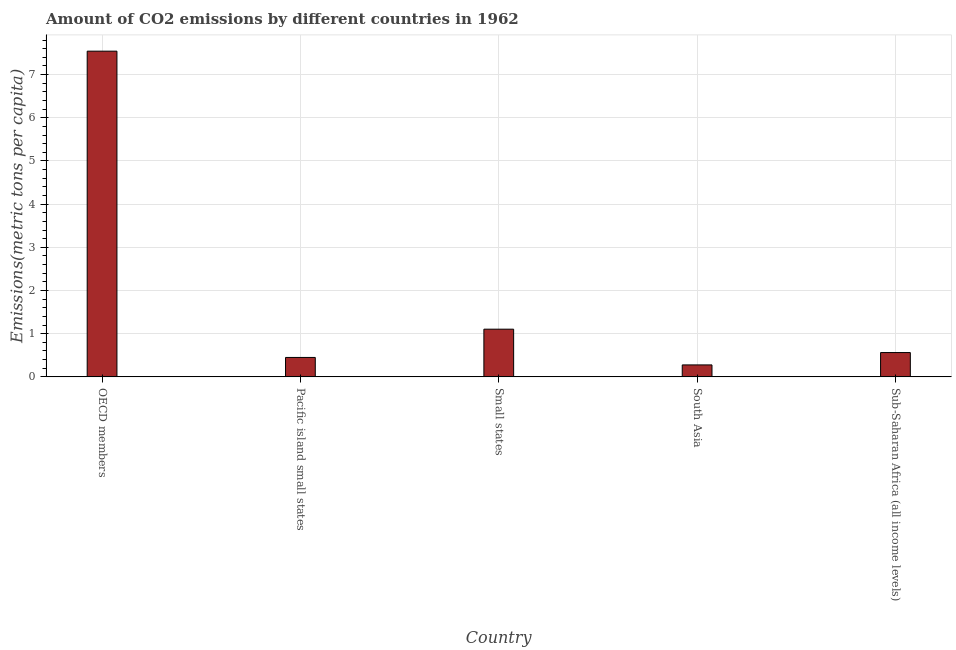What is the title of the graph?
Your answer should be compact. Amount of CO2 emissions by different countries in 1962. What is the label or title of the Y-axis?
Your answer should be compact. Emissions(metric tons per capita). What is the amount of co2 emissions in Sub-Saharan Africa (all income levels)?
Offer a very short reply. 0.56. Across all countries, what is the maximum amount of co2 emissions?
Give a very brief answer. 7.54. Across all countries, what is the minimum amount of co2 emissions?
Ensure brevity in your answer.  0.28. What is the sum of the amount of co2 emissions?
Your answer should be compact. 9.94. What is the difference between the amount of co2 emissions in OECD members and Pacific island small states?
Your answer should be very brief. 7.09. What is the average amount of co2 emissions per country?
Offer a terse response. 1.99. What is the median amount of co2 emissions?
Your answer should be very brief. 0.56. What is the ratio of the amount of co2 emissions in OECD members to that in Small states?
Offer a very short reply. 6.83. Is the amount of co2 emissions in Small states less than that in South Asia?
Your response must be concise. No. Is the difference between the amount of co2 emissions in Pacific island small states and Sub-Saharan Africa (all income levels) greater than the difference between any two countries?
Your answer should be compact. No. What is the difference between the highest and the second highest amount of co2 emissions?
Ensure brevity in your answer.  6.44. What is the difference between the highest and the lowest amount of co2 emissions?
Make the answer very short. 7.26. How many countries are there in the graph?
Your response must be concise. 5. What is the Emissions(metric tons per capita) in OECD members?
Keep it short and to the point. 7.54. What is the Emissions(metric tons per capita) of Pacific island small states?
Your answer should be very brief. 0.45. What is the Emissions(metric tons per capita) of Small states?
Make the answer very short. 1.1. What is the Emissions(metric tons per capita) of South Asia?
Keep it short and to the point. 0.28. What is the Emissions(metric tons per capita) of Sub-Saharan Africa (all income levels)?
Ensure brevity in your answer.  0.56. What is the difference between the Emissions(metric tons per capita) in OECD members and Pacific island small states?
Offer a terse response. 7.09. What is the difference between the Emissions(metric tons per capita) in OECD members and Small states?
Your answer should be very brief. 6.44. What is the difference between the Emissions(metric tons per capita) in OECD members and South Asia?
Make the answer very short. 7.26. What is the difference between the Emissions(metric tons per capita) in OECD members and Sub-Saharan Africa (all income levels)?
Ensure brevity in your answer.  6.98. What is the difference between the Emissions(metric tons per capita) in Pacific island small states and Small states?
Your response must be concise. -0.65. What is the difference between the Emissions(metric tons per capita) in Pacific island small states and South Asia?
Provide a short and direct response. 0.17. What is the difference between the Emissions(metric tons per capita) in Pacific island small states and Sub-Saharan Africa (all income levels)?
Give a very brief answer. -0.11. What is the difference between the Emissions(metric tons per capita) in Small states and South Asia?
Your answer should be compact. 0.83. What is the difference between the Emissions(metric tons per capita) in Small states and Sub-Saharan Africa (all income levels)?
Offer a very short reply. 0.54. What is the difference between the Emissions(metric tons per capita) in South Asia and Sub-Saharan Africa (all income levels)?
Your answer should be very brief. -0.29. What is the ratio of the Emissions(metric tons per capita) in OECD members to that in Pacific island small states?
Your answer should be very brief. 16.77. What is the ratio of the Emissions(metric tons per capita) in OECD members to that in Small states?
Your response must be concise. 6.83. What is the ratio of the Emissions(metric tons per capita) in OECD members to that in South Asia?
Your response must be concise. 27.23. What is the ratio of the Emissions(metric tons per capita) in OECD members to that in Sub-Saharan Africa (all income levels)?
Give a very brief answer. 13.39. What is the ratio of the Emissions(metric tons per capita) in Pacific island small states to that in Small states?
Keep it short and to the point. 0.41. What is the ratio of the Emissions(metric tons per capita) in Pacific island small states to that in South Asia?
Provide a short and direct response. 1.62. What is the ratio of the Emissions(metric tons per capita) in Pacific island small states to that in Sub-Saharan Africa (all income levels)?
Make the answer very short. 0.8. What is the ratio of the Emissions(metric tons per capita) in Small states to that in South Asia?
Your answer should be compact. 3.99. What is the ratio of the Emissions(metric tons per capita) in Small states to that in Sub-Saharan Africa (all income levels)?
Make the answer very short. 1.96. What is the ratio of the Emissions(metric tons per capita) in South Asia to that in Sub-Saharan Africa (all income levels)?
Offer a very short reply. 0.49. 